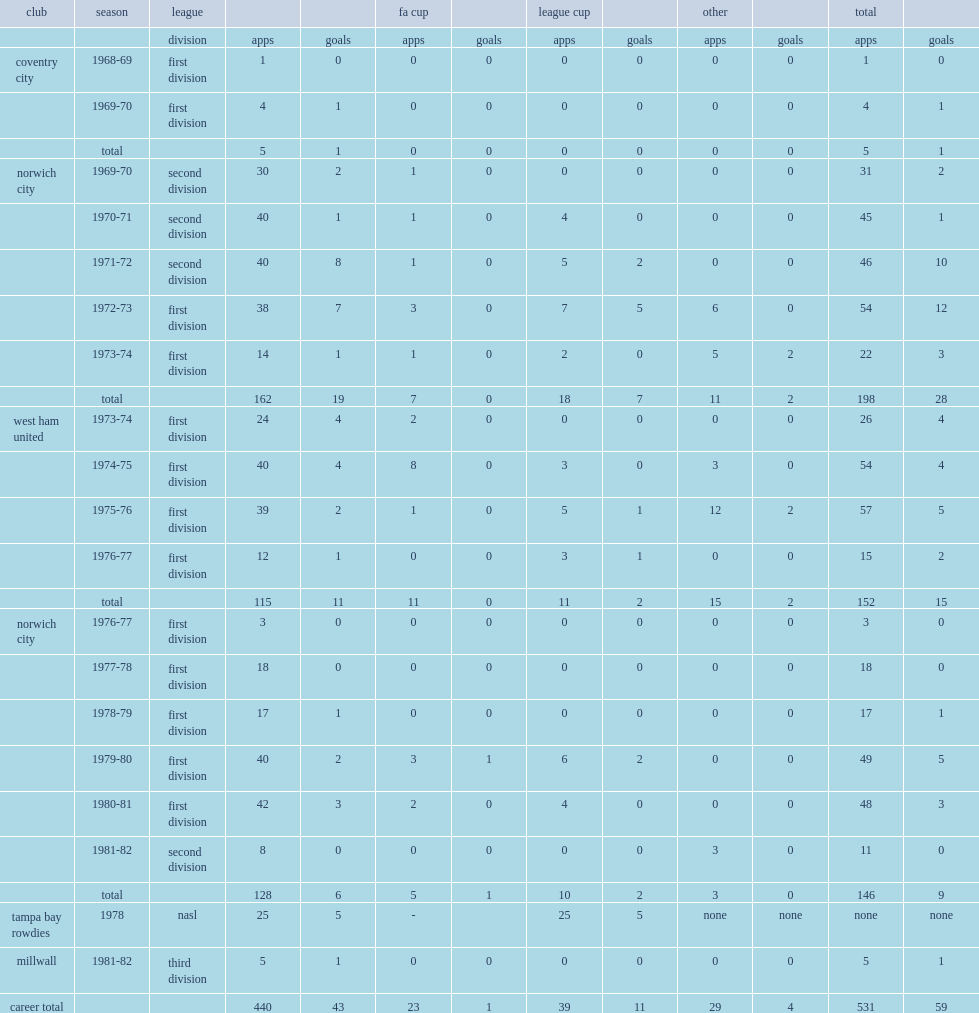How many goals did paddon score for the canaries totally? 28.0. Could you parse the entire table? {'header': ['club', 'season', 'league', '', '', 'fa cup', '', 'league cup', '', 'other', '', 'total', ''], 'rows': [['', '', 'division', 'apps', 'goals', 'apps', 'goals', 'apps', 'goals', 'apps', 'goals', 'apps', 'goals'], ['coventry city', '1968-69', 'first division', '1', '0', '0', '0', '0', '0', '0', '0', '1', '0'], ['', '1969-70', 'first division', '4', '1', '0', '0', '0', '0', '0', '0', '4', '1'], ['', 'total', '', '5', '1', '0', '0', '0', '0', '0', '0', '5', '1'], ['norwich city', '1969-70', 'second division', '30', '2', '1', '0', '0', '0', '0', '0', '31', '2'], ['', '1970-71', 'second division', '40', '1', '1', '0', '4', '0', '0', '0', '45', '1'], ['', '1971-72', 'second division', '40', '8', '1', '0', '5', '2', '0', '0', '46', '10'], ['', '1972-73', 'first division', '38', '7', '3', '0', '7', '5', '6', '0', '54', '12'], ['', '1973-74', 'first division', '14', '1', '1', '0', '2', '0', '5', '2', '22', '3'], ['', 'total', '', '162', '19', '7', '0', '18', '7', '11', '2', '198', '28'], ['west ham united', '1973-74', 'first division', '24', '4', '2', '0', '0', '0', '0', '0', '26', '4'], ['', '1974-75', 'first division', '40', '4', '8', '0', '3', '0', '3', '0', '54', '4'], ['', '1975-76', 'first division', '39', '2', '1', '0', '5', '1', '12', '2', '57', '5'], ['', '1976-77', 'first division', '12', '1', '0', '0', '3', '1', '0', '0', '15', '2'], ['', 'total', '', '115', '11', '11', '0', '11', '2', '15', '2', '152', '15'], ['norwich city', '1976-77', 'first division', '3', '0', '0', '0', '0', '0', '0', '0', '3', '0'], ['', '1977-78', 'first division', '18', '0', '0', '0', '0', '0', '0', '0', '18', '0'], ['', '1978-79', 'first division', '17', '1', '0', '0', '0', '0', '0', '0', '17', '1'], ['', '1979-80', 'first division', '40', '2', '3', '1', '6', '2', '0', '0', '49', '5'], ['', '1980-81', 'first division', '42', '3', '2', '0', '4', '0', '0', '0', '48', '3'], ['', '1981-82', 'second division', '8', '0', '0', '0', '0', '0', '3', '0', '11', '0'], ['', 'total', '', '128', '6', '5', '1', '10', '2', '3', '0', '146', '9'], ['tampa bay rowdies', '1978', 'nasl', '25', '5', '-', '', '25', '5', 'none', 'none', 'none', 'none'], ['millwall', '1981-82', 'third division', '5', '1', '0', '0', '0', '0', '0', '0', '5', '1'], ['career total', '', '', '440', '43', '23', '1', '39', '11', '29', '4', '531', '59']]} 